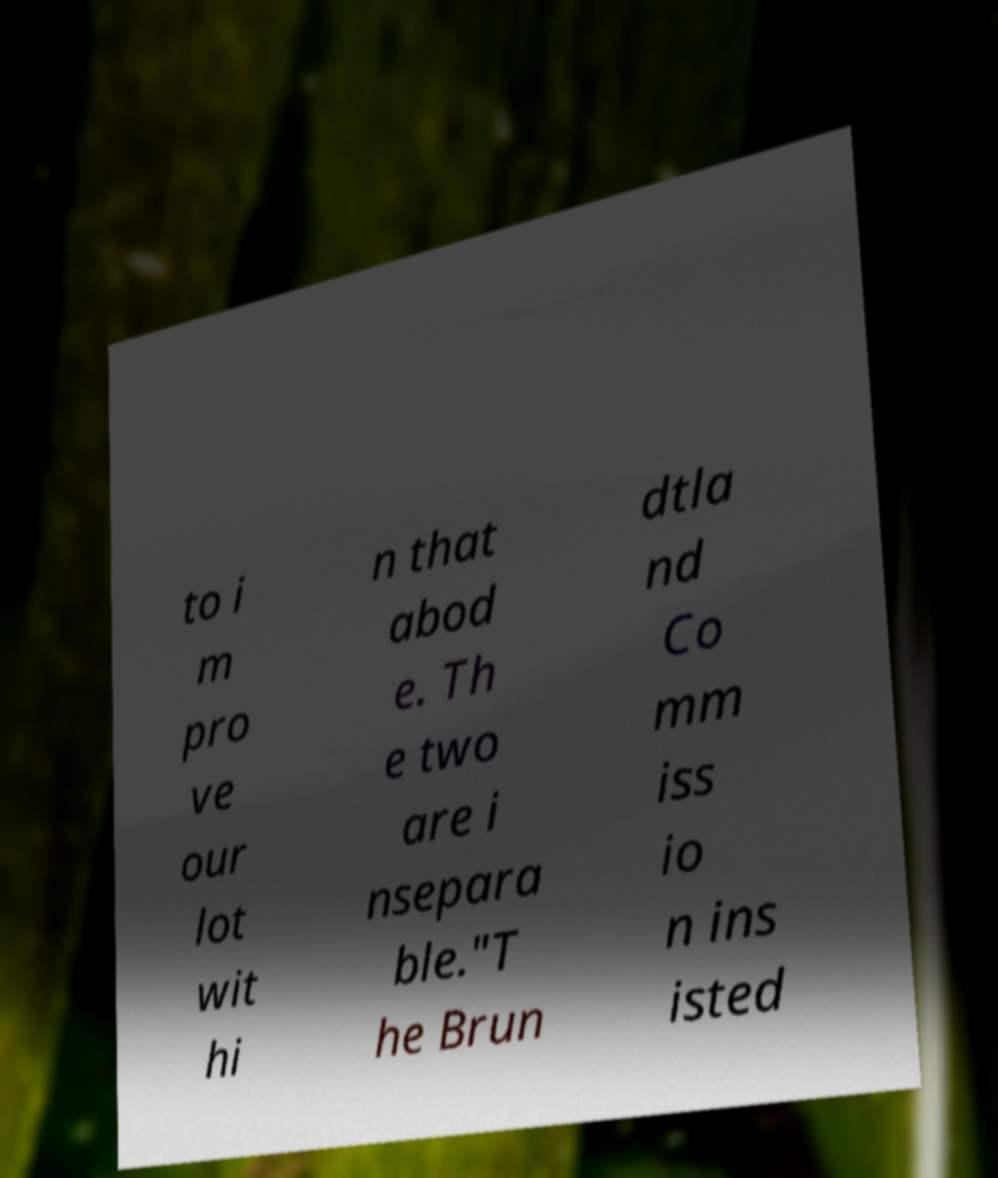Please identify and transcribe the text found in this image. to i m pro ve our lot wit hi n that abod e. Th e two are i nsepara ble."T he Brun dtla nd Co mm iss io n ins isted 